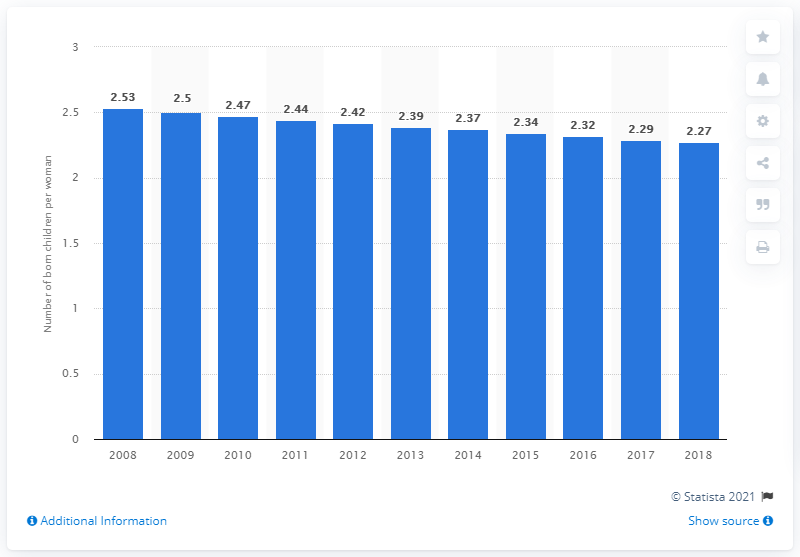Highlight a few significant elements in this photo. In 2018, the fertility rate in Venezuela was 2.27. 